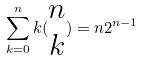Convert formula to latex. <formula><loc_0><loc_0><loc_500><loc_500>\sum _ { k = 0 } ^ { n } k ( \begin{matrix} n \\ k \end{matrix} ) = n 2 ^ { n - 1 }</formula> 